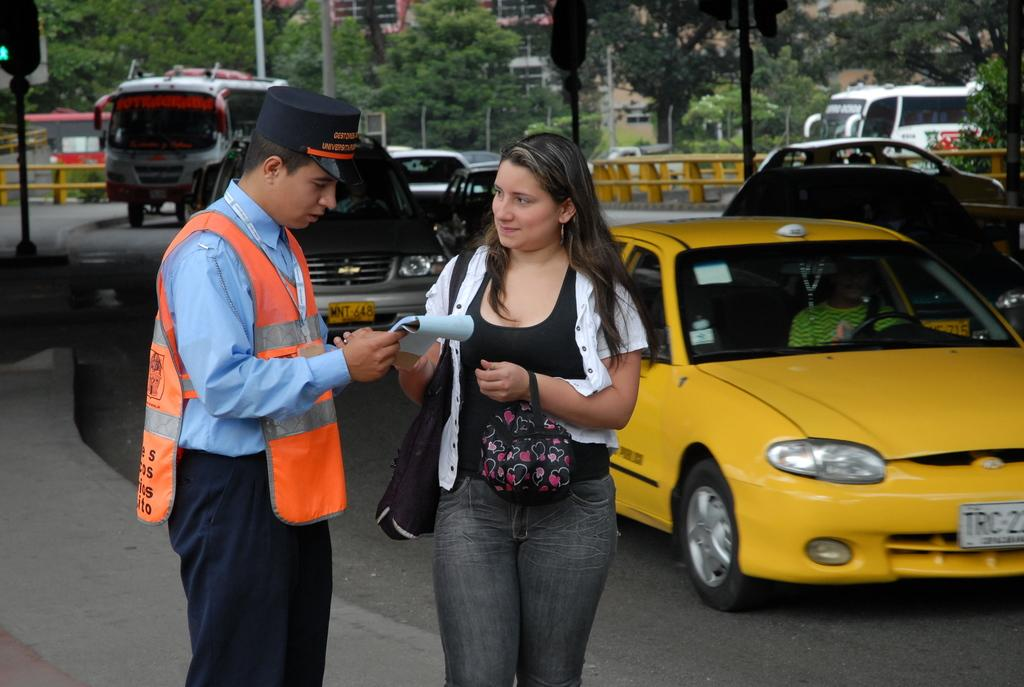<image>
Write a terse but informative summary of the picture. a license plate that has TRC on the plate 